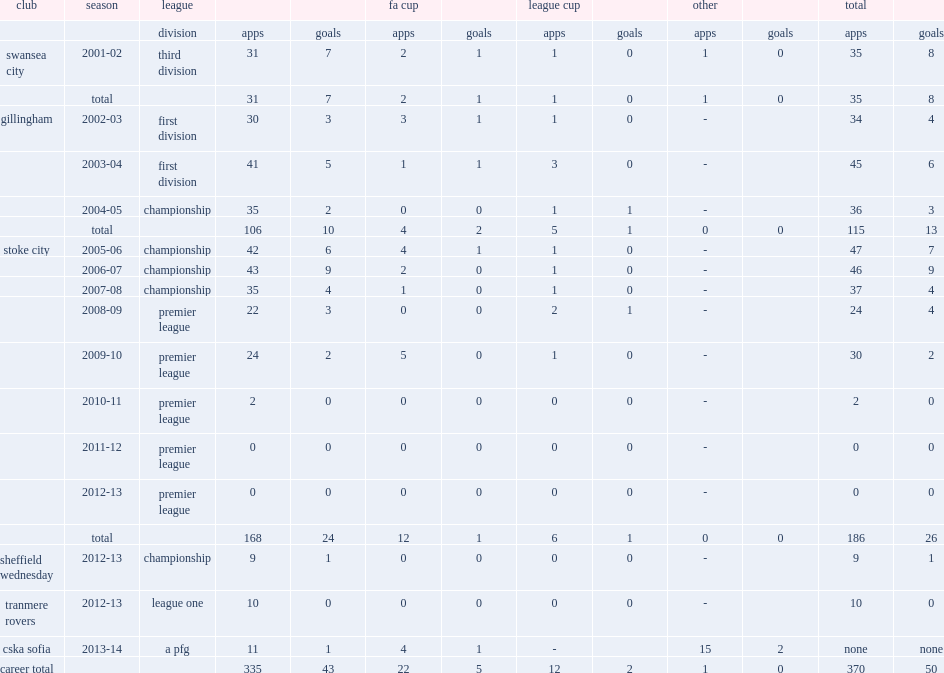How many appearances did mamady sidibe mike for stoke in an eight-year spell? 186.0. 